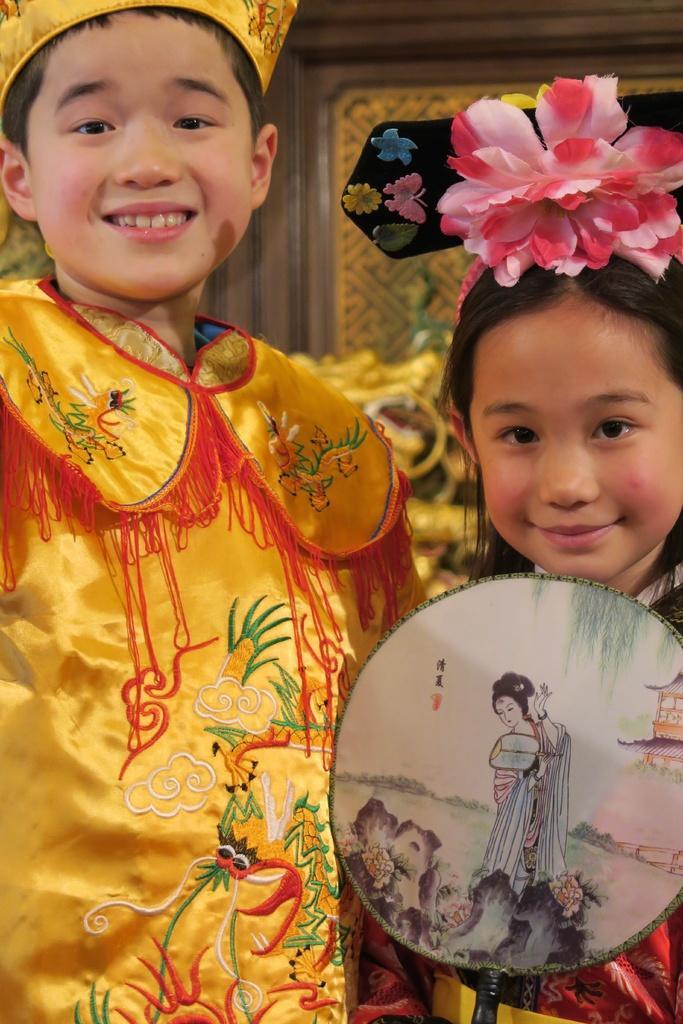How would you summarize this image in a sentence or two? This image consists of two children. One is a boy, another one is a girl. They are wearing same dresses. The girl is holding something. The boy is wearing yellow color dress. 